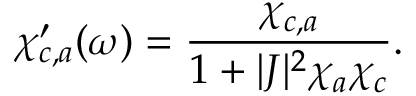Convert formula to latex. <formula><loc_0><loc_0><loc_500><loc_500>\chi _ { c , a } ^ { \prime } ( \omega ) = \frac { \chi _ { c , a } } { 1 + | J | ^ { 2 } \chi _ { a } \chi _ { c } } .</formula> 